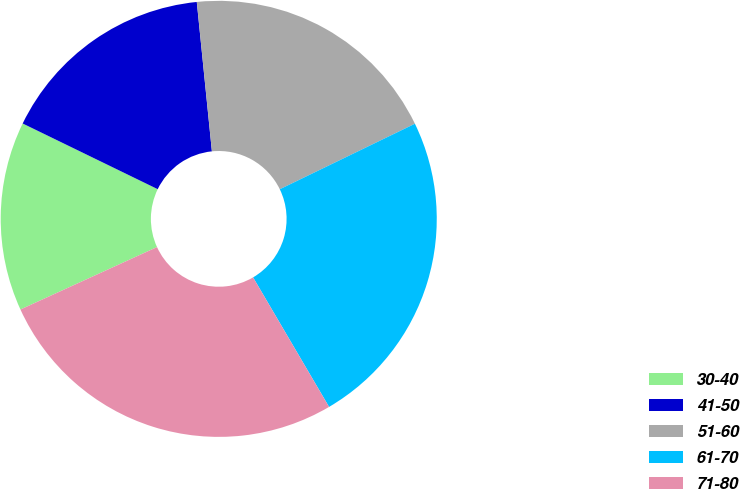Convert chart to OTSL. <chart><loc_0><loc_0><loc_500><loc_500><pie_chart><fcel>30-40<fcel>41-50<fcel>51-60<fcel>61-70<fcel>71-80<nl><fcel>14.03%<fcel>16.19%<fcel>19.42%<fcel>23.74%<fcel>26.62%<nl></chart> 